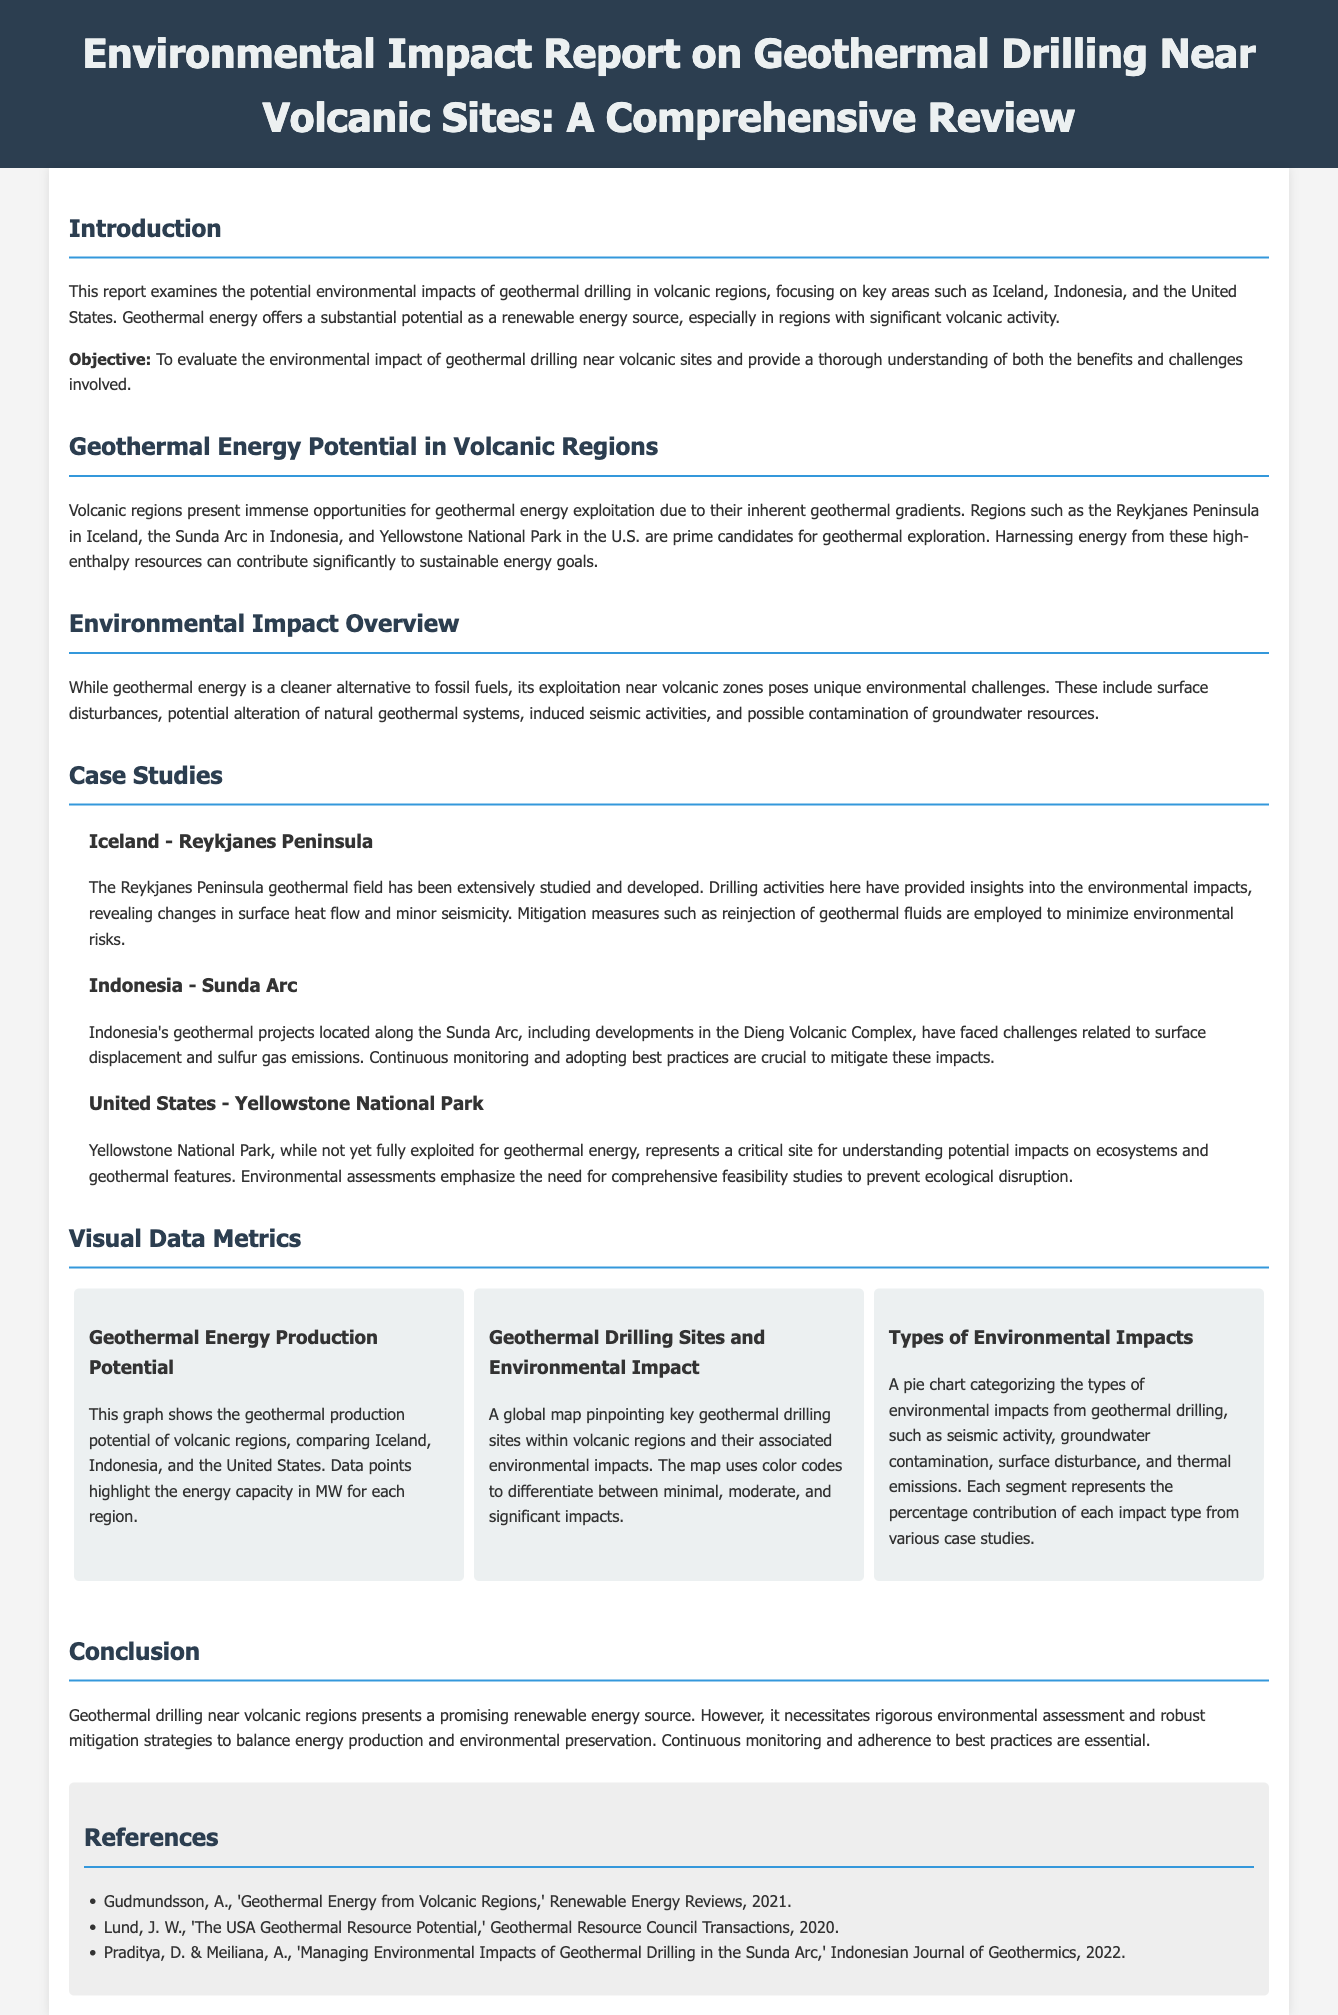What is the focus of the report? The report examines the potential environmental impacts of geothermal drilling in volcanic regions, highlighting significant locations such as Iceland, Indonesia, and the United States.
Answer: Environmental impacts of geothermal drilling What is the geothermal energy production potential of Iceland in MW? The visual data graph indicates the energy capacity in MW for geothermal production potential in volcanic regions, specifically mentioning Iceland among others.
Answer: Data not provided in the document Which volcanic region is noted for changes in surface heat flow and minor seismicity? The report discusses the Reykjanes Peninsula geothermal field in Iceland, detailing its extensive studies and developments.
Answer: Reykjanes Peninsula What categorization is used in the pie chart of environmental impacts? The pie chart illustrates the types of environmental impacts from geothermal drilling, such as seismic activity and groundwater contamination.
Answer: Seismic activity, groundwater contamination, surface disturbance, thermal emissions How does Indonesia's geothermal projects impact the environment? The Sunda Arc geothermal projects in Indonesia have faced challenges related to surface displacement and sulfur gas emissions, requiring continuous monitoring.
Answer: Surface displacement and sulfur gas emissions What needs to be emphasized for Yellowstone National Park? Environmental assessments emphasize the need for comprehensive feasibility studies to avoid ecological disruption in Yellowstone National Park.
Answer: Comprehensive feasibility studies How many case studies are included in the report? The report presents case studies from Iceland, Indonesia, and the United States, showcasing specific geothermal drilling impacts in these areas.
Answer: Three case studies What is essential for mitigating environmental risks in geothermal drilling? The report suggests employing mitigation measures such as reinjection of geothermal fluids to minimize environmental risks associated with geothermal drilling activities.
Answer: Reinjection of geothermal fluids 